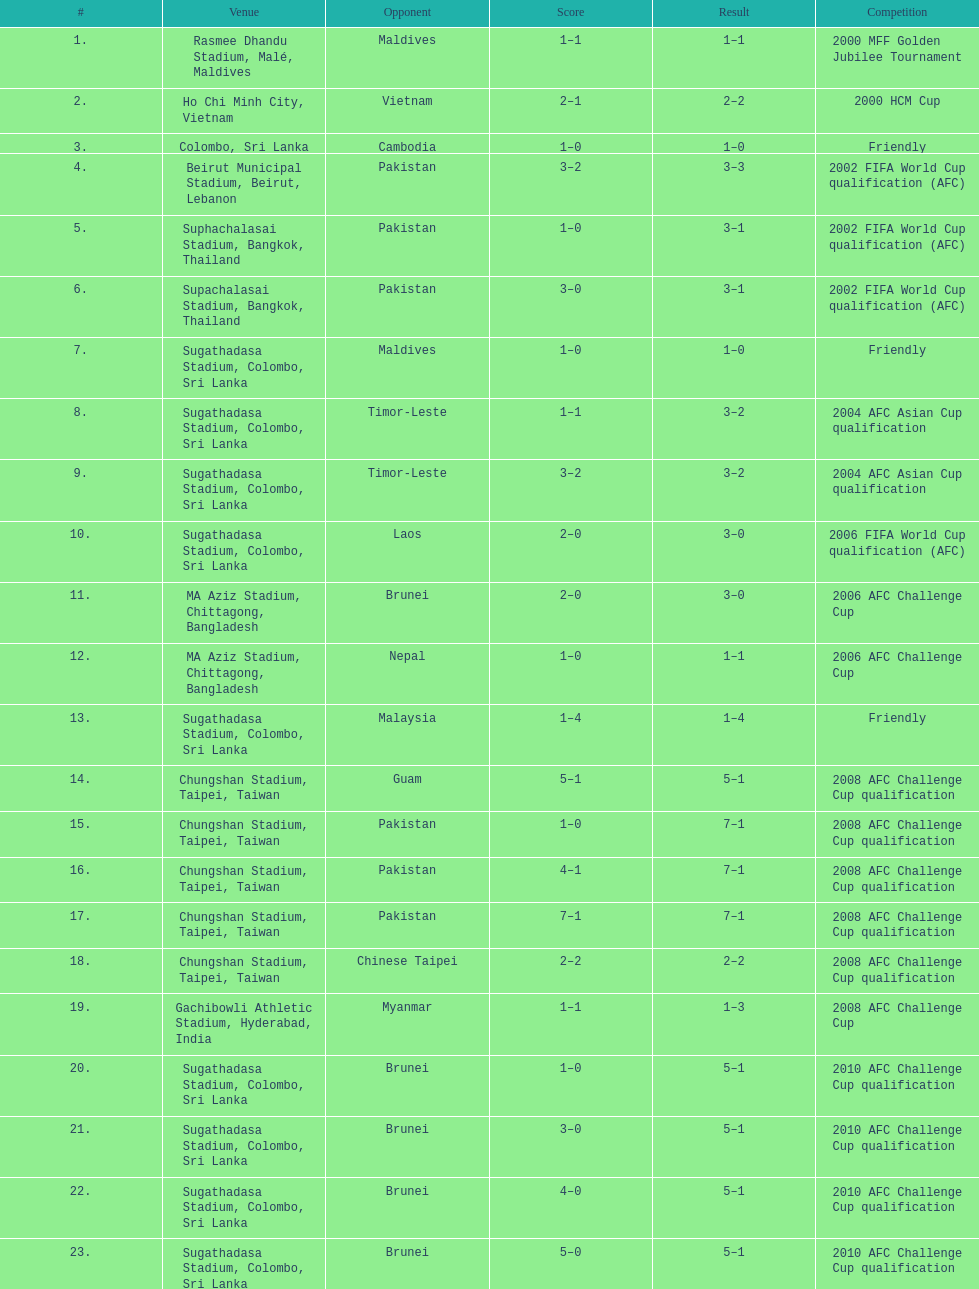How many times was laos the opponent? 1. 